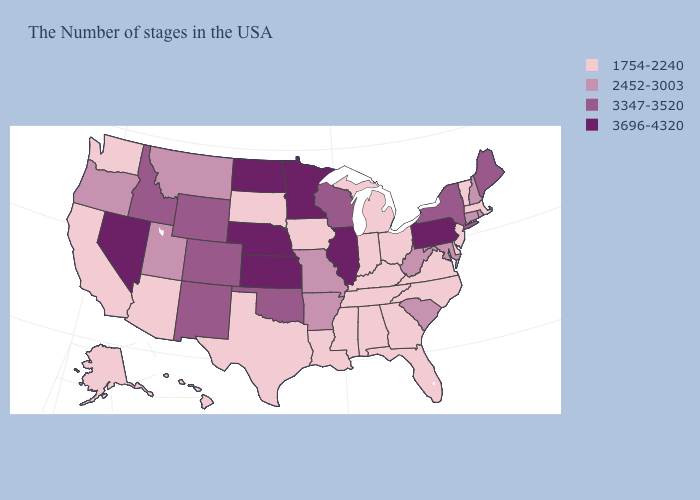Which states have the lowest value in the USA?
Quick response, please. Massachusetts, Vermont, New Jersey, Delaware, Virginia, North Carolina, Ohio, Florida, Georgia, Michigan, Kentucky, Indiana, Alabama, Tennessee, Mississippi, Louisiana, Iowa, Texas, South Dakota, Arizona, California, Washington, Alaska, Hawaii. What is the value of New Hampshire?
Keep it brief. 2452-3003. Does Pennsylvania have the highest value in the USA?
Short answer required. Yes. Name the states that have a value in the range 1754-2240?
Write a very short answer. Massachusetts, Vermont, New Jersey, Delaware, Virginia, North Carolina, Ohio, Florida, Georgia, Michigan, Kentucky, Indiana, Alabama, Tennessee, Mississippi, Louisiana, Iowa, Texas, South Dakota, Arizona, California, Washington, Alaska, Hawaii. What is the value of New Hampshire?
Short answer required. 2452-3003. What is the value of Texas?
Concise answer only. 1754-2240. Does the map have missing data?
Concise answer only. No. Name the states that have a value in the range 3696-4320?
Write a very short answer. Pennsylvania, Illinois, Minnesota, Kansas, Nebraska, North Dakota, Nevada. What is the lowest value in the Northeast?
Concise answer only. 1754-2240. Which states have the lowest value in the South?
Answer briefly. Delaware, Virginia, North Carolina, Florida, Georgia, Kentucky, Alabama, Tennessee, Mississippi, Louisiana, Texas. What is the value of Wyoming?
Keep it brief. 3347-3520. What is the value of Pennsylvania?
Be succinct. 3696-4320. Among the states that border Wisconsin , which have the highest value?
Short answer required. Illinois, Minnesota. Is the legend a continuous bar?
Be succinct. No. 